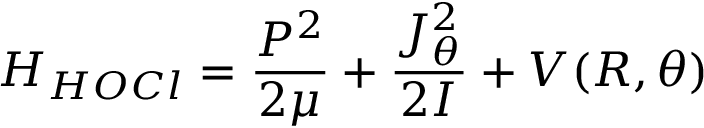<formula> <loc_0><loc_0><loc_500><loc_500>H _ { H O C l } = \frac { P ^ { 2 } } { 2 \mu } + \frac { J _ { \theta } ^ { 2 } } { 2 I } + V ( R , \theta )</formula> 